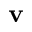<formula> <loc_0><loc_0><loc_500><loc_500>{ \mathbf v }</formula> 